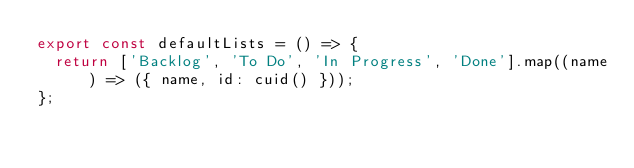<code> <loc_0><loc_0><loc_500><loc_500><_TypeScript_>export const defaultLists = () => {
  return ['Backlog', 'To Do', 'In Progress', 'Done'].map((name) => ({ name, id: cuid() }));
};
</code> 